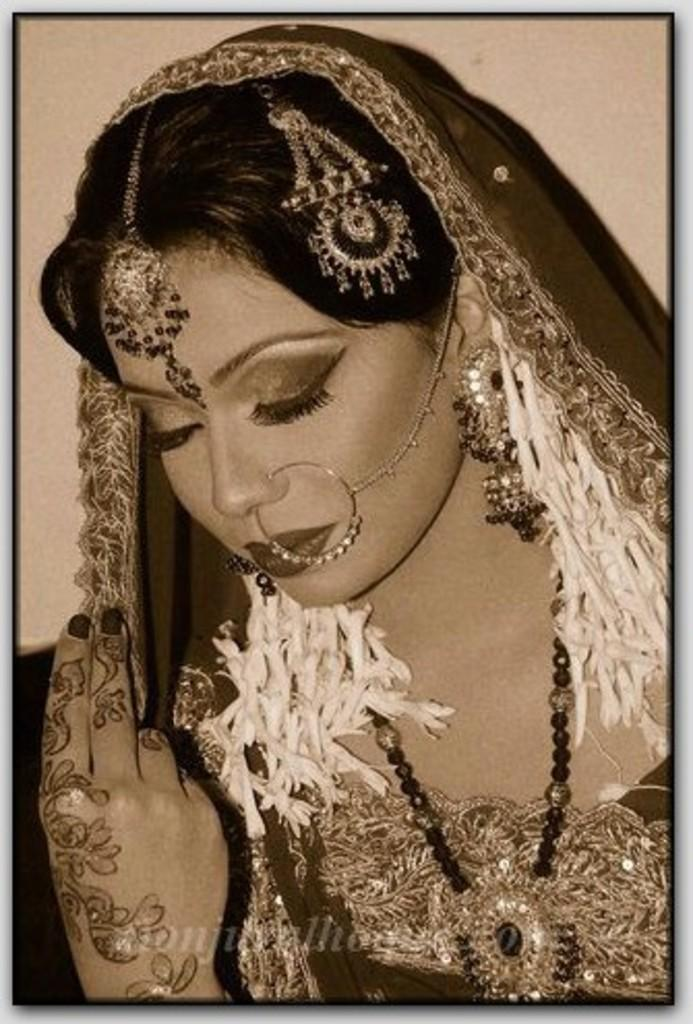Who is the main subject in the image? There is a lady in the image. What is the lady wearing? The lady is wearing a sari. Are there any accessories or ornaments visible on the lady? Yes, the lady is wearing ornaments. What is the lady doing in the image? The lady is posing for a photograph. What type of duck can be seen in the image? There is no duck present in the image. Is the lady holding a rifle in the image? No, the lady is not holding a rifle in the image. 